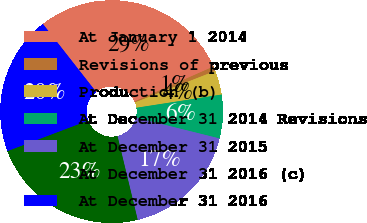<chart> <loc_0><loc_0><loc_500><loc_500><pie_chart><fcel>At January 1 2014<fcel>Revisions of previous<fcel>Production (b)<fcel>At December 31 2014 Revisions<fcel>At December 31 2015<fcel>At December 31 2016 (c)<fcel>At December 31 2016<nl><fcel>28.95%<fcel>0.68%<fcel>3.5%<fcel>6.33%<fcel>17.35%<fcel>23.01%<fcel>20.18%<nl></chart> 